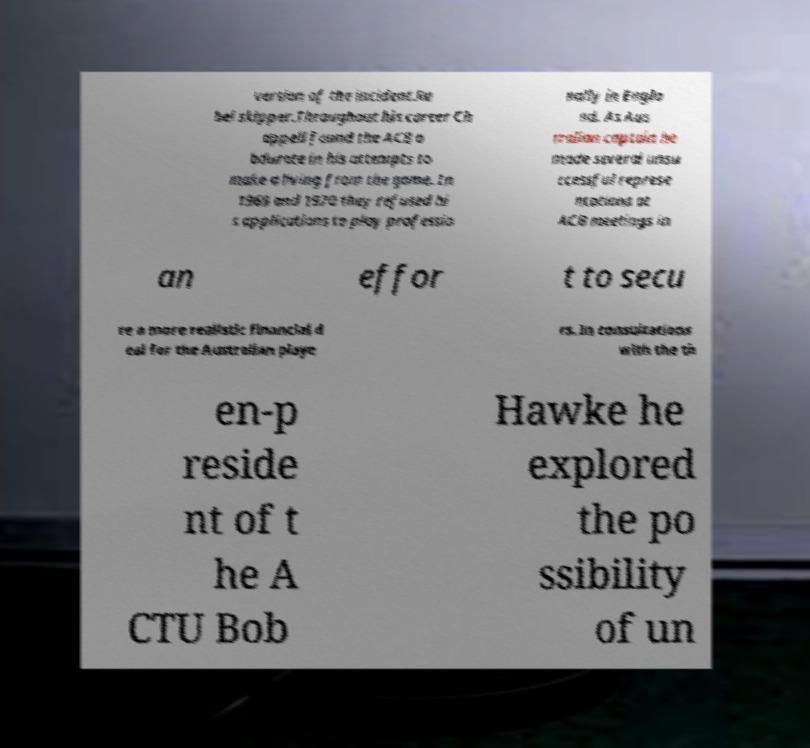What messages or text are displayed in this image? I need them in a readable, typed format. version of the incident.Re bel skipper.Throughout his career Ch appell found the ACB o bdurate in his attempts to make a living from the game. In 1969 and 1970 they refused hi s applications to play professio nally in Engla nd. As Aus tralian captain he made several unsu ccessful represe ntations at ACB meetings in an effor t to secu re a more realistic financial d eal for the Australian playe rs. In consultations with the th en-p reside nt of t he A CTU Bob Hawke he explored the po ssibility of un 